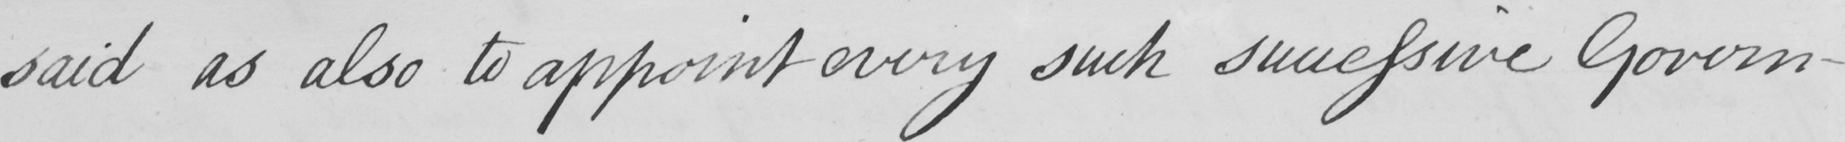Can you read and transcribe this handwriting? -said as also to appoint every such successive Govern- 